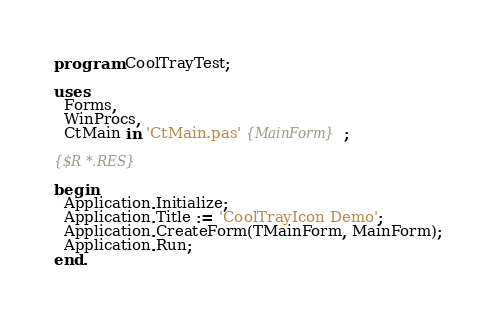Convert code to text. <code><loc_0><loc_0><loc_500><loc_500><_Pascal_>program CoolTrayTest;

uses
  Forms,
  WinProcs,
  CtMain in 'CtMain.pas' {MainForm};

{$R *.RES}

begin
  Application.Initialize;
  Application.Title := 'CoolTrayIcon Demo';
  Application.CreateForm(TMainForm, MainForm);
  Application.Run;
end.
</code> 